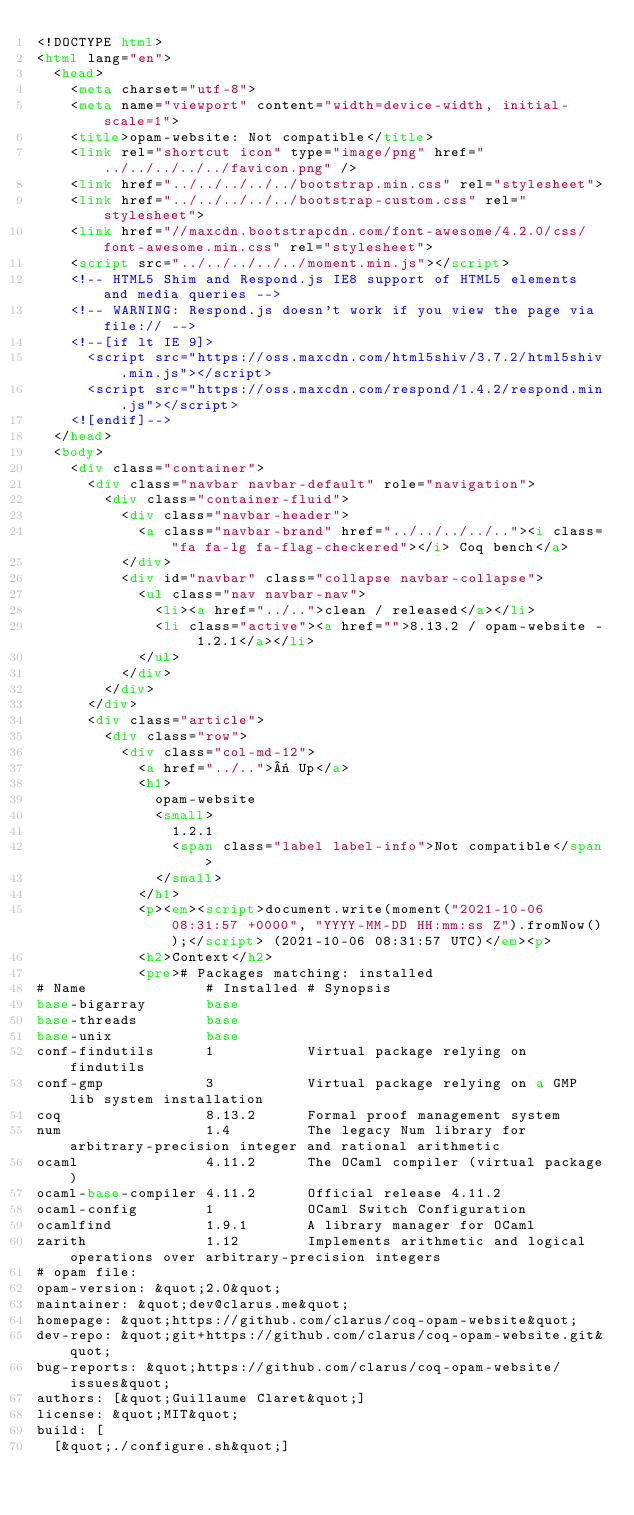Convert code to text. <code><loc_0><loc_0><loc_500><loc_500><_HTML_><!DOCTYPE html>
<html lang="en">
  <head>
    <meta charset="utf-8">
    <meta name="viewport" content="width=device-width, initial-scale=1">
    <title>opam-website: Not compatible</title>
    <link rel="shortcut icon" type="image/png" href="../../../../../favicon.png" />
    <link href="../../../../../bootstrap.min.css" rel="stylesheet">
    <link href="../../../../../bootstrap-custom.css" rel="stylesheet">
    <link href="//maxcdn.bootstrapcdn.com/font-awesome/4.2.0/css/font-awesome.min.css" rel="stylesheet">
    <script src="../../../../../moment.min.js"></script>
    <!-- HTML5 Shim and Respond.js IE8 support of HTML5 elements and media queries -->
    <!-- WARNING: Respond.js doesn't work if you view the page via file:// -->
    <!--[if lt IE 9]>
      <script src="https://oss.maxcdn.com/html5shiv/3.7.2/html5shiv.min.js"></script>
      <script src="https://oss.maxcdn.com/respond/1.4.2/respond.min.js"></script>
    <![endif]-->
  </head>
  <body>
    <div class="container">
      <div class="navbar navbar-default" role="navigation">
        <div class="container-fluid">
          <div class="navbar-header">
            <a class="navbar-brand" href="../../../../.."><i class="fa fa-lg fa-flag-checkered"></i> Coq bench</a>
          </div>
          <div id="navbar" class="collapse navbar-collapse">
            <ul class="nav navbar-nav">
              <li><a href="../..">clean / released</a></li>
              <li class="active"><a href="">8.13.2 / opam-website - 1.2.1</a></li>
            </ul>
          </div>
        </div>
      </div>
      <div class="article">
        <div class="row">
          <div class="col-md-12">
            <a href="../..">« Up</a>
            <h1>
              opam-website
              <small>
                1.2.1
                <span class="label label-info">Not compatible</span>
              </small>
            </h1>
            <p><em><script>document.write(moment("2021-10-06 08:31:57 +0000", "YYYY-MM-DD HH:mm:ss Z").fromNow());</script> (2021-10-06 08:31:57 UTC)</em><p>
            <h2>Context</h2>
            <pre># Packages matching: installed
# Name              # Installed # Synopsis
base-bigarray       base
base-threads        base
base-unix           base
conf-findutils      1           Virtual package relying on findutils
conf-gmp            3           Virtual package relying on a GMP lib system installation
coq                 8.13.2      Formal proof management system
num                 1.4         The legacy Num library for arbitrary-precision integer and rational arithmetic
ocaml               4.11.2      The OCaml compiler (virtual package)
ocaml-base-compiler 4.11.2      Official release 4.11.2
ocaml-config        1           OCaml Switch Configuration
ocamlfind           1.9.1       A library manager for OCaml
zarith              1.12        Implements arithmetic and logical operations over arbitrary-precision integers
# opam file:
opam-version: &quot;2.0&quot;
maintainer: &quot;dev@clarus.me&quot;
homepage: &quot;https://github.com/clarus/coq-opam-website&quot;
dev-repo: &quot;git+https://github.com/clarus/coq-opam-website.git&quot;
bug-reports: &quot;https://github.com/clarus/coq-opam-website/issues&quot;
authors: [&quot;Guillaume Claret&quot;]
license: &quot;MIT&quot;
build: [
  [&quot;./configure.sh&quot;]</code> 